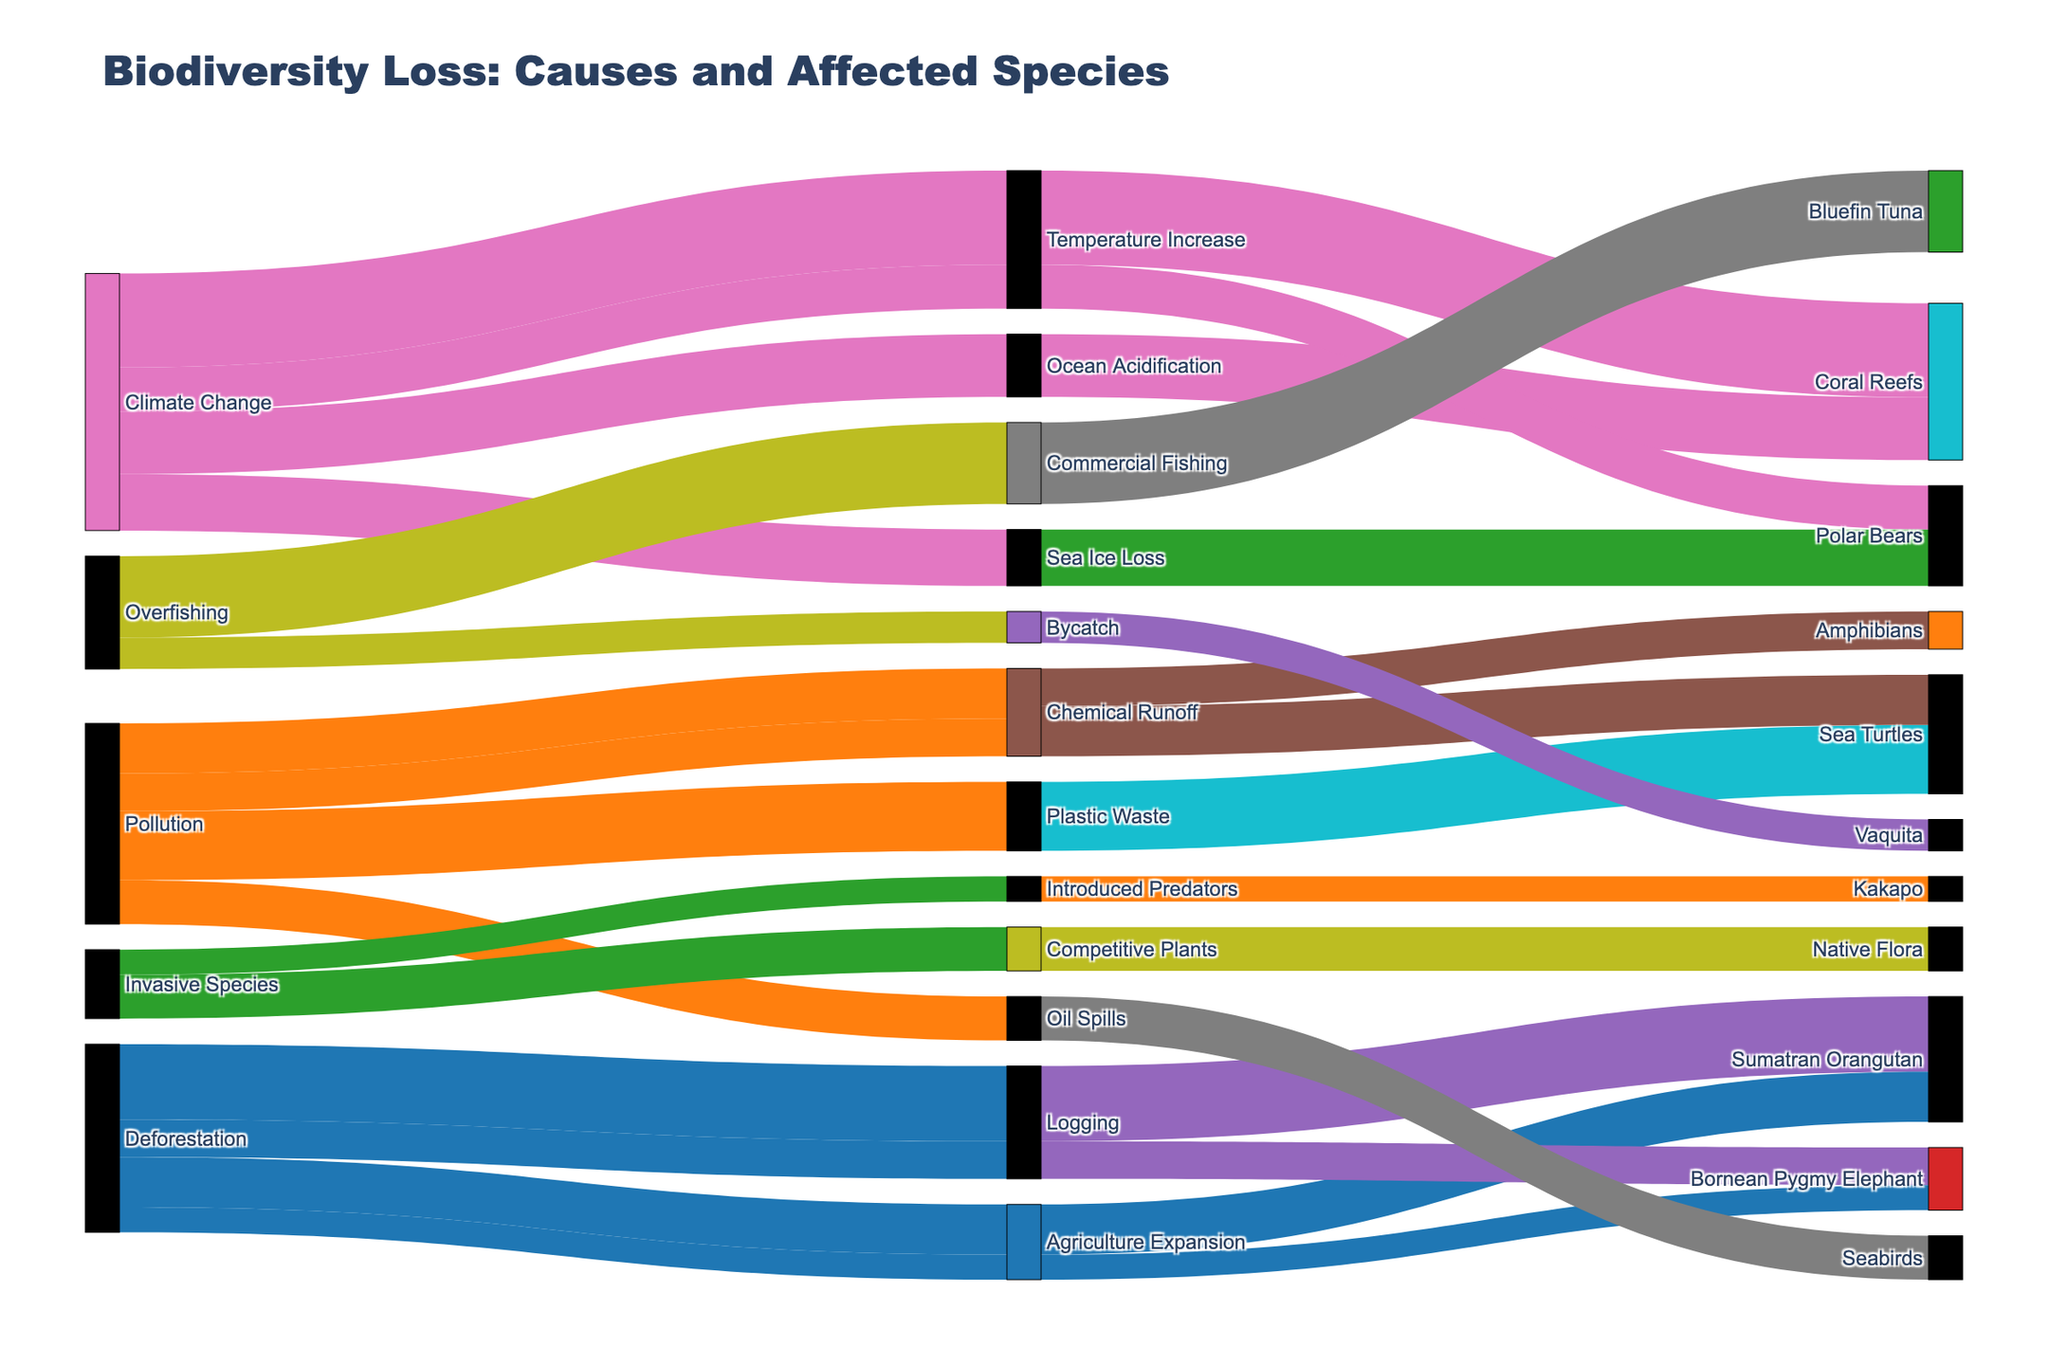What is the title of the diagram? Look at the top of the diagram where the title is usually located. Here, the title is "Biodiversity Loss: Causes and Affected Species".
Answer: Biodiversity Loss: Causes and Affected Species Which species are affected by deforestation due to logging? Follow the flow starting from "Deforestation" to "Logging" and see which species are in the final layer.
Answer: Sumatran Orangutan, Bornean Pygmy Elephant How many species are affected by pollution due to chemical runoff, and what are they? Starting from "Pollution", follow the path to "Chemical Runoff" to see the species linked, which are "Sea Turtles" and "Amphibians". Count these species.
Answer: 2, Sea Turtles, Amphibians What is the highest impact caused by climate change, and which species does it affect? Follow the flows from "Climate Change" and look for the path with the highest number. The highest impact has a value of 150 and affects "Coral Reefs".
Answer: 150, Coral Reefs What is the total impact on polar bears due to climate change? Identify the paths leading to "Polar Bears" from "Climate Change". Sum the impacts from "Temperature Increase" (70) and "Sea Ice Loss" (90).
Answer: 160 Which cause has the highest total impact on all affected species? Sum the impacts for each cause over all affected species. For deforestation: 300, Climate Change: 410, Pollution: 320, Overfishing: 180, Invasive Species: 110. Climate Change has the highest total impact.
Answer: Climate Change Compare the impacts of plastic waste and chemical runoff on sea turtles. Which is higher and by how much? Track the paths from "Plastic Waste" and "Chemical Runoff" to "Sea Turtles". Plastic Waste has an impact of 110 and Chemical Runoff has 80. The difference is 110 - 80.
Answer: Plastic Waste, 30 Which species affected by deforestation has the least impact and what is the value? Examine the species affected by "Deforestation". The impacts are 120, 80, 60, and 40. The lowest impact is 40 on Bornean Pygmy Elephant.
Answer: Bornean Pygmy Elephant, 40 What impact does commercial fishing have on overfished species? Follow the flows from "Overfishing" to "Commercial Fishing" to the affected species "Bluefin Tuna". The impact value is 130.
Answer: 130 How many species are affected by invasive species, and what is the total impact? Identify the flows from "Invasive Species" to the affected species. Count the distinct species (Kakapo, Native Flora) and sum the impacts (40 + 70).
Answer: 2, 110 